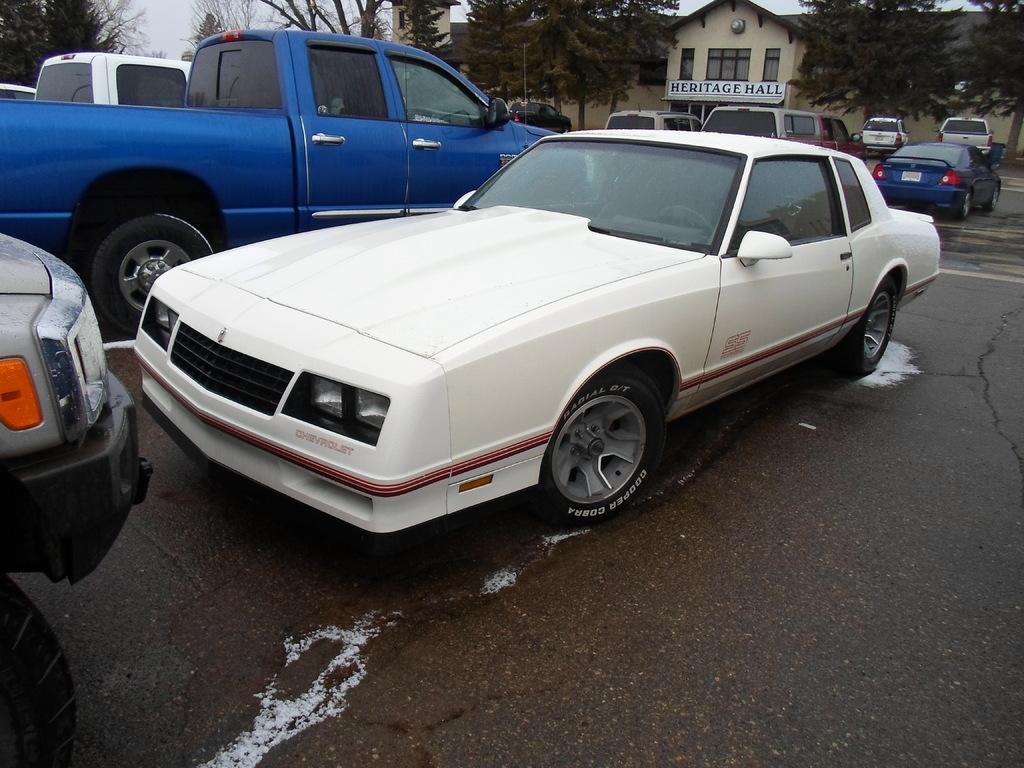What can be seen on the road in the image? There are cars on the road in the image. What type of natural elements are visible in the background? There are trees in the background of the image. What type of man-made structures can be seen in the background? There is at least one building in the background of the image. Can you see a kitten playing chess with a clam in the image? No, there is no kitten, chess, or clam present in the image. 